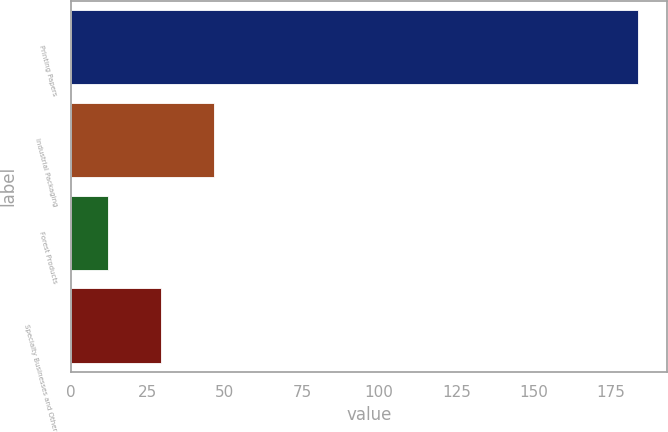Convert chart to OTSL. <chart><loc_0><loc_0><loc_500><loc_500><bar_chart><fcel>Printing Papers<fcel>Industrial Packaging<fcel>Forest Products<fcel>Specialty Businesses and Other<nl><fcel>184<fcel>46.4<fcel>12<fcel>29.2<nl></chart> 